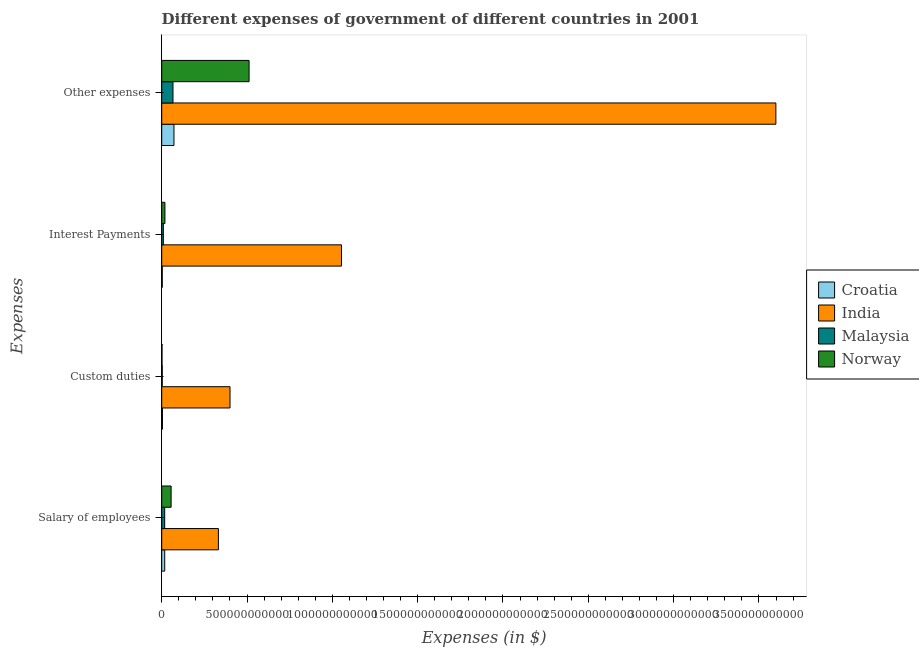How many different coloured bars are there?
Offer a terse response. 4. How many groups of bars are there?
Provide a succinct answer. 4. Are the number of bars per tick equal to the number of legend labels?
Provide a succinct answer. Yes. How many bars are there on the 2nd tick from the top?
Your answer should be compact. 4. How many bars are there on the 4th tick from the bottom?
Your answer should be compact. 4. What is the label of the 3rd group of bars from the top?
Offer a terse response. Custom duties. What is the amount spent on other expenses in India?
Ensure brevity in your answer.  3.60e+12. Across all countries, what is the maximum amount spent on custom duties?
Your answer should be compact. 4.00e+11. Across all countries, what is the minimum amount spent on interest payments?
Your response must be concise. 3.26e+09. In which country was the amount spent on custom duties maximum?
Give a very brief answer. India. In which country was the amount spent on other expenses minimum?
Give a very brief answer. Malaysia. What is the total amount spent on other expenses in the graph?
Your answer should be very brief. 4.25e+12. What is the difference between the amount spent on interest payments in Norway and that in Malaysia?
Your answer should be compact. 9.21e+09. What is the difference between the amount spent on custom duties in Norway and the amount spent on interest payments in Croatia?
Provide a short and direct response. -1.50e+09. What is the average amount spent on interest payments per country?
Your answer should be compact. 2.71e+11. What is the difference between the amount spent on custom duties and amount spent on other expenses in Croatia?
Your answer should be very brief. -6.76e+1. In how many countries, is the amount spent on salary of employees greater than 1300000000000 $?
Offer a terse response. 0. What is the ratio of the amount spent on custom duties in India to that in Croatia?
Your answer should be compact. 94.64. What is the difference between the highest and the second highest amount spent on other expenses?
Make the answer very short. 3.09e+12. What is the difference between the highest and the lowest amount spent on salary of employees?
Keep it short and to the point. 3.15e+11. Is the sum of the amount spent on interest payments in Croatia and Norway greater than the maximum amount spent on custom duties across all countries?
Provide a succinct answer. No. Is it the case that in every country, the sum of the amount spent on other expenses and amount spent on custom duties is greater than the sum of amount spent on salary of employees and amount spent on interest payments?
Offer a very short reply. No. What does the 4th bar from the top in Salary of employees represents?
Offer a terse response. Croatia. How many bars are there?
Provide a succinct answer. 16. What is the difference between two consecutive major ticks on the X-axis?
Provide a short and direct response. 5.00e+11. Does the graph contain any zero values?
Give a very brief answer. No. Does the graph contain grids?
Provide a succinct answer. No. What is the title of the graph?
Make the answer very short. Different expenses of government of different countries in 2001. Does "Niger" appear as one of the legend labels in the graph?
Make the answer very short. No. What is the label or title of the X-axis?
Offer a very short reply. Expenses (in $). What is the label or title of the Y-axis?
Make the answer very short. Expenses. What is the Expenses (in $) in Croatia in Salary of employees?
Provide a succinct answer. 1.76e+1. What is the Expenses (in $) in India in Salary of employees?
Provide a short and direct response. 3.32e+11. What is the Expenses (in $) of Malaysia in Salary of employees?
Make the answer very short. 1.74e+1. What is the Expenses (in $) in Norway in Salary of employees?
Make the answer very short. 5.51e+1. What is the Expenses (in $) of Croatia in Custom duties?
Give a very brief answer. 4.23e+09. What is the Expenses (in $) in India in Custom duties?
Keep it short and to the point. 4.00e+11. What is the Expenses (in $) in Malaysia in Custom duties?
Give a very brief answer. 3.19e+09. What is the Expenses (in $) of Norway in Custom duties?
Your answer should be compact. 1.76e+09. What is the Expenses (in $) in Croatia in Interest Payments?
Offer a very short reply. 3.26e+09. What is the Expenses (in $) in India in Interest Payments?
Your answer should be very brief. 1.05e+12. What is the Expenses (in $) in Malaysia in Interest Payments?
Your answer should be very brief. 9.63e+09. What is the Expenses (in $) in Norway in Interest Payments?
Ensure brevity in your answer.  1.88e+1. What is the Expenses (in $) of Croatia in Other expenses?
Keep it short and to the point. 7.18e+1. What is the Expenses (in $) of India in Other expenses?
Your answer should be very brief. 3.60e+12. What is the Expenses (in $) in Malaysia in Other expenses?
Your response must be concise. 6.61e+1. What is the Expenses (in $) of Norway in Other expenses?
Provide a short and direct response. 5.12e+11. Across all Expenses, what is the maximum Expenses (in $) of Croatia?
Offer a terse response. 7.18e+1. Across all Expenses, what is the maximum Expenses (in $) in India?
Give a very brief answer. 3.60e+12. Across all Expenses, what is the maximum Expenses (in $) of Malaysia?
Give a very brief answer. 6.61e+1. Across all Expenses, what is the maximum Expenses (in $) of Norway?
Your response must be concise. 5.12e+11. Across all Expenses, what is the minimum Expenses (in $) in Croatia?
Your answer should be compact. 3.26e+09. Across all Expenses, what is the minimum Expenses (in $) of India?
Ensure brevity in your answer.  3.32e+11. Across all Expenses, what is the minimum Expenses (in $) of Malaysia?
Offer a very short reply. 3.19e+09. Across all Expenses, what is the minimum Expenses (in $) of Norway?
Ensure brevity in your answer.  1.76e+09. What is the total Expenses (in $) of Croatia in the graph?
Offer a terse response. 9.69e+1. What is the total Expenses (in $) of India in the graph?
Your answer should be very brief. 5.39e+12. What is the total Expenses (in $) in Malaysia in the graph?
Provide a succinct answer. 9.64e+1. What is the total Expenses (in $) in Norway in the graph?
Offer a terse response. 5.88e+11. What is the difference between the Expenses (in $) of Croatia in Salary of employees and that in Custom duties?
Keep it short and to the point. 1.34e+1. What is the difference between the Expenses (in $) of India in Salary of employees and that in Custom duties?
Ensure brevity in your answer.  -6.80e+1. What is the difference between the Expenses (in $) of Malaysia in Salary of employees and that in Custom duties?
Provide a short and direct response. 1.42e+1. What is the difference between the Expenses (in $) in Norway in Salary of employees and that in Custom duties?
Your answer should be very brief. 5.33e+1. What is the difference between the Expenses (in $) of Croatia in Salary of employees and that in Interest Payments?
Make the answer very short. 1.44e+1. What is the difference between the Expenses (in $) of India in Salary of employees and that in Interest Payments?
Provide a short and direct response. -7.21e+11. What is the difference between the Expenses (in $) of Malaysia in Salary of employees and that in Interest Payments?
Make the answer very short. 7.81e+09. What is the difference between the Expenses (in $) in Norway in Salary of employees and that in Interest Payments?
Your answer should be compact. 3.62e+1. What is the difference between the Expenses (in $) in Croatia in Salary of employees and that in Other expenses?
Your response must be concise. -5.42e+1. What is the difference between the Expenses (in $) of India in Salary of employees and that in Other expenses?
Make the answer very short. -3.27e+12. What is the difference between the Expenses (in $) in Malaysia in Salary of employees and that in Other expenses?
Ensure brevity in your answer.  -4.86e+1. What is the difference between the Expenses (in $) of Norway in Salary of employees and that in Other expenses?
Your answer should be very brief. -4.57e+11. What is the difference between the Expenses (in $) in Croatia in Custom duties and that in Interest Payments?
Give a very brief answer. 9.70e+08. What is the difference between the Expenses (in $) in India in Custom duties and that in Interest Payments?
Provide a succinct answer. -6.53e+11. What is the difference between the Expenses (in $) in Malaysia in Custom duties and that in Interest Payments?
Offer a terse response. -6.44e+09. What is the difference between the Expenses (in $) of Norway in Custom duties and that in Interest Payments?
Your response must be concise. -1.71e+1. What is the difference between the Expenses (in $) in Croatia in Custom duties and that in Other expenses?
Your response must be concise. -6.76e+1. What is the difference between the Expenses (in $) in India in Custom duties and that in Other expenses?
Keep it short and to the point. -3.20e+12. What is the difference between the Expenses (in $) of Malaysia in Custom duties and that in Other expenses?
Provide a succinct answer. -6.29e+1. What is the difference between the Expenses (in $) of Norway in Custom duties and that in Other expenses?
Your answer should be compact. -5.10e+11. What is the difference between the Expenses (in $) of Croatia in Interest Payments and that in Other expenses?
Ensure brevity in your answer.  -6.85e+1. What is the difference between the Expenses (in $) in India in Interest Payments and that in Other expenses?
Ensure brevity in your answer.  -2.55e+12. What is the difference between the Expenses (in $) of Malaysia in Interest Payments and that in Other expenses?
Your response must be concise. -5.65e+1. What is the difference between the Expenses (in $) of Norway in Interest Payments and that in Other expenses?
Provide a succinct answer. -4.93e+11. What is the difference between the Expenses (in $) in Croatia in Salary of employees and the Expenses (in $) in India in Custom duties?
Offer a very short reply. -3.83e+11. What is the difference between the Expenses (in $) of Croatia in Salary of employees and the Expenses (in $) of Malaysia in Custom duties?
Provide a short and direct response. 1.44e+1. What is the difference between the Expenses (in $) of Croatia in Salary of employees and the Expenses (in $) of Norway in Custom duties?
Provide a succinct answer. 1.59e+1. What is the difference between the Expenses (in $) of India in Salary of employees and the Expenses (in $) of Malaysia in Custom duties?
Give a very brief answer. 3.29e+11. What is the difference between the Expenses (in $) in India in Salary of employees and the Expenses (in $) in Norway in Custom duties?
Your response must be concise. 3.31e+11. What is the difference between the Expenses (in $) in Malaysia in Salary of employees and the Expenses (in $) in Norway in Custom duties?
Keep it short and to the point. 1.57e+1. What is the difference between the Expenses (in $) of Croatia in Salary of employees and the Expenses (in $) of India in Interest Payments?
Provide a short and direct response. -1.04e+12. What is the difference between the Expenses (in $) in Croatia in Salary of employees and the Expenses (in $) in Malaysia in Interest Payments?
Keep it short and to the point. 8.00e+09. What is the difference between the Expenses (in $) of Croatia in Salary of employees and the Expenses (in $) of Norway in Interest Payments?
Your response must be concise. -1.21e+09. What is the difference between the Expenses (in $) in India in Salary of employees and the Expenses (in $) in Malaysia in Interest Payments?
Provide a succinct answer. 3.23e+11. What is the difference between the Expenses (in $) of India in Salary of employees and the Expenses (in $) of Norway in Interest Payments?
Offer a terse response. 3.13e+11. What is the difference between the Expenses (in $) in Malaysia in Salary of employees and the Expenses (in $) in Norway in Interest Payments?
Your response must be concise. -1.40e+09. What is the difference between the Expenses (in $) in Croatia in Salary of employees and the Expenses (in $) in India in Other expenses?
Provide a succinct answer. -3.58e+12. What is the difference between the Expenses (in $) of Croatia in Salary of employees and the Expenses (in $) of Malaysia in Other expenses?
Ensure brevity in your answer.  -4.85e+1. What is the difference between the Expenses (in $) of Croatia in Salary of employees and the Expenses (in $) of Norway in Other expenses?
Offer a very short reply. -4.94e+11. What is the difference between the Expenses (in $) in India in Salary of employees and the Expenses (in $) in Malaysia in Other expenses?
Make the answer very short. 2.66e+11. What is the difference between the Expenses (in $) of India in Salary of employees and the Expenses (in $) of Norway in Other expenses?
Keep it short and to the point. -1.80e+11. What is the difference between the Expenses (in $) in Malaysia in Salary of employees and the Expenses (in $) in Norway in Other expenses?
Offer a terse response. -4.95e+11. What is the difference between the Expenses (in $) in Croatia in Custom duties and the Expenses (in $) in India in Interest Payments?
Provide a succinct answer. -1.05e+12. What is the difference between the Expenses (in $) of Croatia in Custom duties and the Expenses (in $) of Malaysia in Interest Payments?
Give a very brief answer. -5.40e+09. What is the difference between the Expenses (in $) in Croatia in Custom duties and the Expenses (in $) in Norway in Interest Payments?
Provide a short and direct response. -1.46e+1. What is the difference between the Expenses (in $) of India in Custom duties and the Expenses (in $) of Malaysia in Interest Payments?
Offer a very short reply. 3.91e+11. What is the difference between the Expenses (in $) in India in Custom duties and the Expenses (in $) in Norway in Interest Payments?
Your answer should be compact. 3.81e+11. What is the difference between the Expenses (in $) in Malaysia in Custom duties and the Expenses (in $) in Norway in Interest Payments?
Make the answer very short. -1.56e+1. What is the difference between the Expenses (in $) of Croatia in Custom duties and the Expenses (in $) of India in Other expenses?
Keep it short and to the point. -3.59e+12. What is the difference between the Expenses (in $) of Croatia in Custom duties and the Expenses (in $) of Malaysia in Other expenses?
Your answer should be very brief. -6.19e+1. What is the difference between the Expenses (in $) in Croatia in Custom duties and the Expenses (in $) in Norway in Other expenses?
Provide a succinct answer. -5.08e+11. What is the difference between the Expenses (in $) in India in Custom duties and the Expenses (in $) in Malaysia in Other expenses?
Make the answer very short. 3.34e+11. What is the difference between the Expenses (in $) in India in Custom duties and the Expenses (in $) in Norway in Other expenses?
Keep it short and to the point. -1.12e+11. What is the difference between the Expenses (in $) in Malaysia in Custom duties and the Expenses (in $) in Norway in Other expenses?
Provide a short and direct response. -5.09e+11. What is the difference between the Expenses (in $) of Croatia in Interest Payments and the Expenses (in $) of India in Other expenses?
Keep it short and to the point. -3.60e+12. What is the difference between the Expenses (in $) in Croatia in Interest Payments and the Expenses (in $) in Malaysia in Other expenses?
Provide a short and direct response. -6.28e+1. What is the difference between the Expenses (in $) in Croatia in Interest Payments and the Expenses (in $) in Norway in Other expenses?
Keep it short and to the point. -5.09e+11. What is the difference between the Expenses (in $) of India in Interest Payments and the Expenses (in $) of Malaysia in Other expenses?
Provide a succinct answer. 9.87e+11. What is the difference between the Expenses (in $) of India in Interest Payments and the Expenses (in $) of Norway in Other expenses?
Your response must be concise. 5.42e+11. What is the difference between the Expenses (in $) in Malaysia in Interest Payments and the Expenses (in $) in Norway in Other expenses?
Offer a very short reply. -5.02e+11. What is the average Expenses (in $) of Croatia per Expenses?
Your answer should be compact. 2.42e+1. What is the average Expenses (in $) of India per Expenses?
Your response must be concise. 1.35e+12. What is the average Expenses (in $) of Malaysia per Expenses?
Your answer should be very brief. 2.41e+1. What is the average Expenses (in $) in Norway per Expenses?
Keep it short and to the point. 1.47e+11. What is the difference between the Expenses (in $) of Croatia and Expenses (in $) of India in Salary of employees?
Provide a succinct answer. -3.15e+11. What is the difference between the Expenses (in $) of Croatia and Expenses (in $) of Malaysia in Salary of employees?
Offer a very short reply. 1.87e+08. What is the difference between the Expenses (in $) in Croatia and Expenses (in $) in Norway in Salary of employees?
Your answer should be compact. -3.75e+1. What is the difference between the Expenses (in $) of India and Expenses (in $) of Malaysia in Salary of employees?
Ensure brevity in your answer.  3.15e+11. What is the difference between the Expenses (in $) of India and Expenses (in $) of Norway in Salary of employees?
Give a very brief answer. 2.77e+11. What is the difference between the Expenses (in $) of Malaysia and Expenses (in $) of Norway in Salary of employees?
Provide a short and direct response. -3.76e+1. What is the difference between the Expenses (in $) in Croatia and Expenses (in $) in India in Custom duties?
Make the answer very short. -3.96e+11. What is the difference between the Expenses (in $) in Croatia and Expenses (in $) in Malaysia in Custom duties?
Offer a terse response. 1.04e+09. What is the difference between the Expenses (in $) in Croatia and Expenses (in $) in Norway in Custom duties?
Make the answer very short. 2.47e+09. What is the difference between the Expenses (in $) of India and Expenses (in $) of Malaysia in Custom duties?
Your answer should be very brief. 3.97e+11. What is the difference between the Expenses (in $) in India and Expenses (in $) in Norway in Custom duties?
Your answer should be very brief. 3.99e+11. What is the difference between the Expenses (in $) in Malaysia and Expenses (in $) in Norway in Custom duties?
Make the answer very short. 1.43e+09. What is the difference between the Expenses (in $) in Croatia and Expenses (in $) in India in Interest Payments?
Give a very brief answer. -1.05e+12. What is the difference between the Expenses (in $) of Croatia and Expenses (in $) of Malaysia in Interest Payments?
Your response must be concise. -6.37e+09. What is the difference between the Expenses (in $) of Croatia and Expenses (in $) of Norway in Interest Payments?
Make the answer very short. -1.56e+1. What is the difference between the Expenses (in $) of India and Expenses (in $) of Malaysia in Interest Payments?
Keep it short and to the point. 1.04e+12. What is the difference between the Expenses (in $) in India and Expenses (in $) in Norway in Interest Payments?
Give a very brief answer. 1.03e+12. What is the difference between the Expenses (in $) in Malaysia and Expenses (in $) in Norway in Interest Payments?
Your answer should be very brief. -9.21e+09. What is the difference between the Expenses (in $) of Croatia and Expenses (in $) of India in Other expenses?
Make the answer very short. -3.53e+12. What is the difference between the Expenses (in $) of Croatia and Expenses (in $) of Malaysia in Other expenses?
Offer a very short reply. 5.71e+09. What is the difference between the Expenses (in $) of Croatia and Expenses (in $) of Norway in Other expenses?
Ensure brevity in your answer.  -4.40e+11. What is the difference between the Expenses (in $) of India and Expenses (in $) of Malaysia in Other expenses?
Keep it short and to the point. 3.53e+12. What is the difference between the Expenses (in $) of India and Expenses (in $) of Norway in Other expenses?
Offer a terse response. 3.09e+12. What is the difference between the Expenses (in $) of Malaysia and Expenses (in $) of Norway in Other expenses?
Your answer should be very brief. -4.46e+11. What is the ratio of the Expenses (in $) of Croatia in Salary of employees to that in Custom duties?
Your response must be concise. 4.17. What is the ratio of the Expenses (in $) in India in Salary of employees to that in Custom duties?
Make the answer very short. 0.83. What is the ratio of the Expenses (in $) in Malaysia in Salary of employees to that in Custom duties?
Provide a succinct answer. 5.46. What is the ratio of the Expenses (in $) in Norway in Salary of employees to that in Custom duties?
Offer a very short reply. 31.25. What is the ratio of the Expenses (in $) in Croatia in Salary of employees to that in Interest Payments?
Give a very brief answer. 5.41. What is the ratio of the Expenses (in $) in India in Salary of employees to that in Interest Payments?
Make the answer very short. 0.32. What is the ratio of the Expenses (in $) in Malaysia in Salary of employees to that in Interest Payments?
Provide a short and direct response. 1.81. What is the ratio of the Expenses (in $) in Norway in Salary of employees to that in Interest Payments?
Ensure brevity in your answer.  2.92. What is the ratio of the Expenses (in $) of Croatia in Salary of employees to that in Other expenses?
Your answer should be very brief. 0.25. What is the ratio of the Expenses (in $) in India in Salary of employees to that in Other expenses?
Provide a short and direct response. 0.09. What is the ratio of the Expenses (in $) in Malaysia in Salary of employees to that in Other expenses?
Your response must be concise. 0.26. What is the ratio of the Expenses (in $) of Norway in Salary of employees to that in Other expenses?
Keep it short and to the point. 0.11. What is the ratio of the Expenses (in $) in Croatia in Custom duties to that in Interest Payments?
Make the answer very short. 1.3. What is the ratio of the Expenses (in $) in India in Custom duties to that in Interest Payments?
Keep it short and to the point. 0.38. What is the ratio of the Expenses (in $) in Malaysia in Custom duties to that in Interest Payments?
Provide a succinct answer. 0.33. What is the ratio of the Expenses (in $) of Norway in Custom duties to that in Interest Payments?
Keep it short and to the point. 0.09. What is the ratio of the Expenses (in $) of Croatia in Custom duties to that in Other expenses?
Keep it short and to the point. 0.06. What is the ratio of the Expenses (in $) in India in Custom duties to that in Other expenses?
Your response must be concise. 0.11. What is the ratio of the Expenses (in $) in Malaysia in Custom duties to that in Other expenses?
Offer a terse response. 0.05. What is the ratio of the Expenses (in $) of Norway in Custom duties to that in Other expenses?
Provide a succinct answer. 0. What is the ratio of the Expenses (in $) of Croatia in Interest Payments to that in Other expenses?
Provide a succinct answer. 0.05. What is the ratio of the Expenses (in $) in India in Interest Payments to that in Other expenses?
Give a very brief answer. 0.29. What is the ratio of the Expenses (in $) in Malaysia in Interest Payments to that in Other expenses?
Offer a very short reply. 0.15. What is the ratio of the Expenses (in $) in Norway in Interest Payments to that in Other expenses?
Your answer should be compact. 0.04. What is the difference between the highest and the second highest Expenses (in $) in Croatia?
Offer a terse response. 5.42e+1. What is the difference between the highest and the second highest Expenses (in $) of India?
Your answer should be very brief. 2.55e+12. What is the difference between the highest and the second highest Expenses (in $) in Malaysia?
Your answer should be compact. 4.86e+1. What is the difference between the highest and the second highest Expenses (in $) of Norway?
Your answer should be very brief. 4.57e+11. What is the difference between the highest and the lowest Expenses (in $) in Croatia?
Your response must be concise. 6.85e+1. What is the difference between the highest and the lowest Expenses (in $) in India?
Offer a very short reply. 3.27e+12. What is the difference between the highest and the lowest Expenses (in $) of Malaysia?
Make the answer very short. 6.29e+1. What is the difference between the highest and the lowest Expenses (in $) in Norway?
Your answer should be very brief. 5.10e+11. 